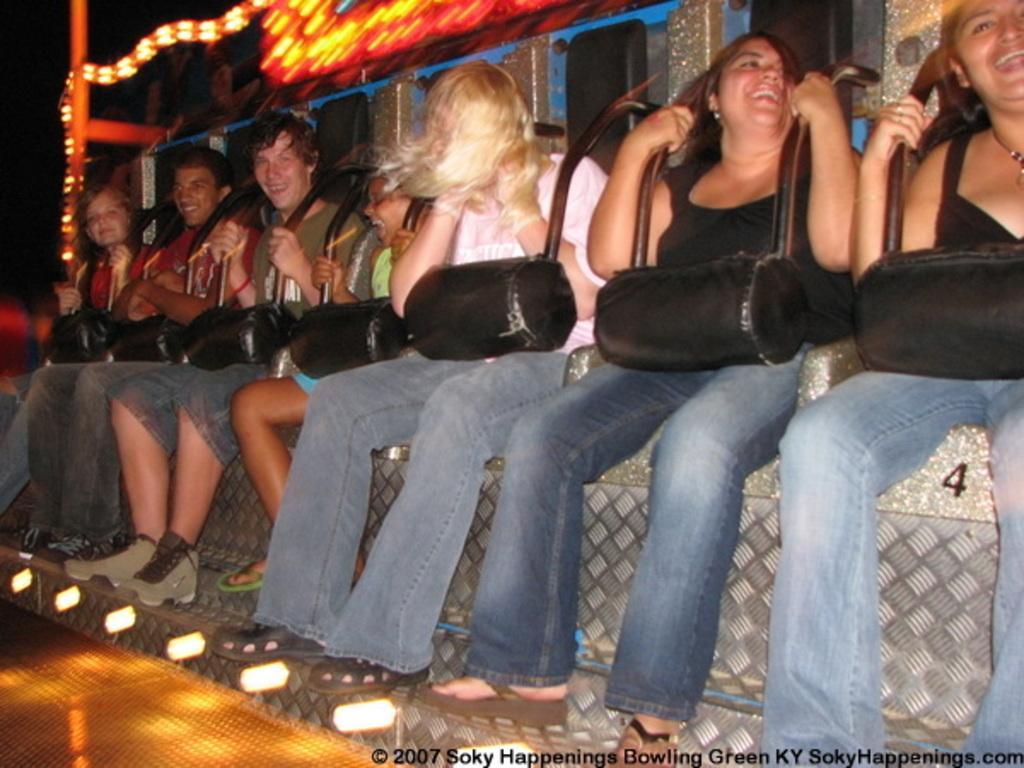Can you describe this image briefly? In this picture we can see there are groups of people sitting on an object. Behind the people there are lights and a dark background. 